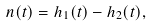Convert formula to latex. <formula><loc_0><loc_0><loc_500><loc_500>n ( t ) = h _ { 1 } ( t ) - h _ { 2 } ( t ) ,</formula> 